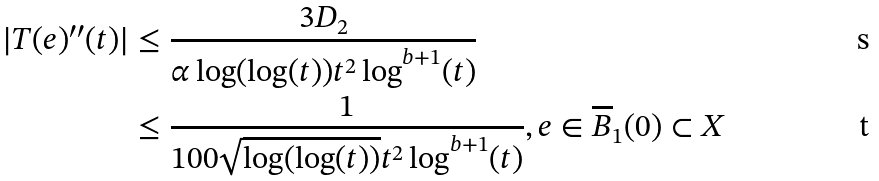<formula> <loc_0><loc_0><loc_500><loc_500>| T ( e ) ^ { \prime \prime } ( t ) | & \leq \frac { 3 D _ { 2 } } { \alpha \log ( \log ( t ) ) t ^ { 2 } \log ^ { b + 1 } ( t ) } \\ & \leq \frac { 1 } { 1 0 0 \sqrt { \log ( \log ( t ) ) } t ^ { 2 } \log ^ { b + 1 } ( t ) } , e \in \overline { B } _ { 1 } ( 0 ) \subset X</formula> 